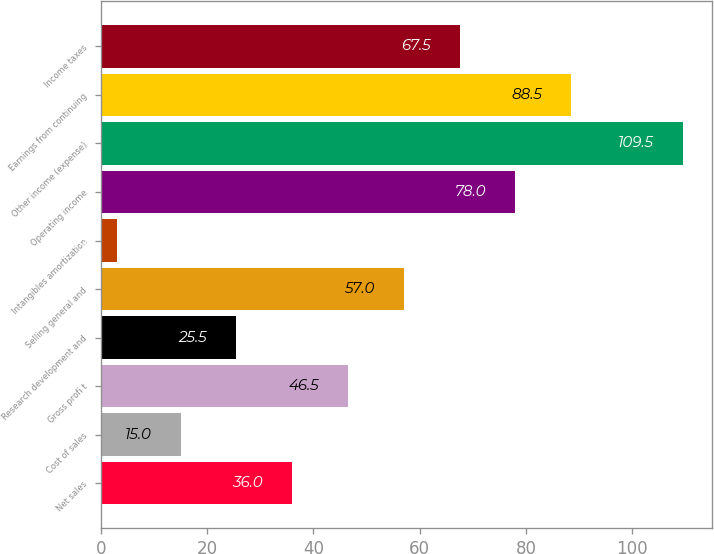Convert chart to OTSL. <chart><loc_0><loc_0><loc_500><loc_500><bar_chart><fcel>Net sales<fcel>Cost of sales<fcel>Gross profi t<fcel>Research development and<fcel>Selling general and<fcel>Intangibles amortization<fcel>Operating income<fcel>Other income (expense)<fcel>Earnings from continuing<fcel>Income taxes<nl><fcel>36<fcel>15<fcel>46.5<fcel>25.5<fcel>57<fcel>3<fcel>78<fcel>109.5<fcel>88.5<fcel>67.5<nl></chart> 